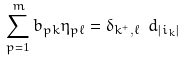Convert formula to latex. <formula><loc_0><loc_0><loc_500><loc_500>\sum _ { p = 1 } ^ { m } b _ { p k } \eta _ { p \ell } = \delta _ { k ^ { + } , \ell } \ d _ { | i _ { k } | }</formula> 